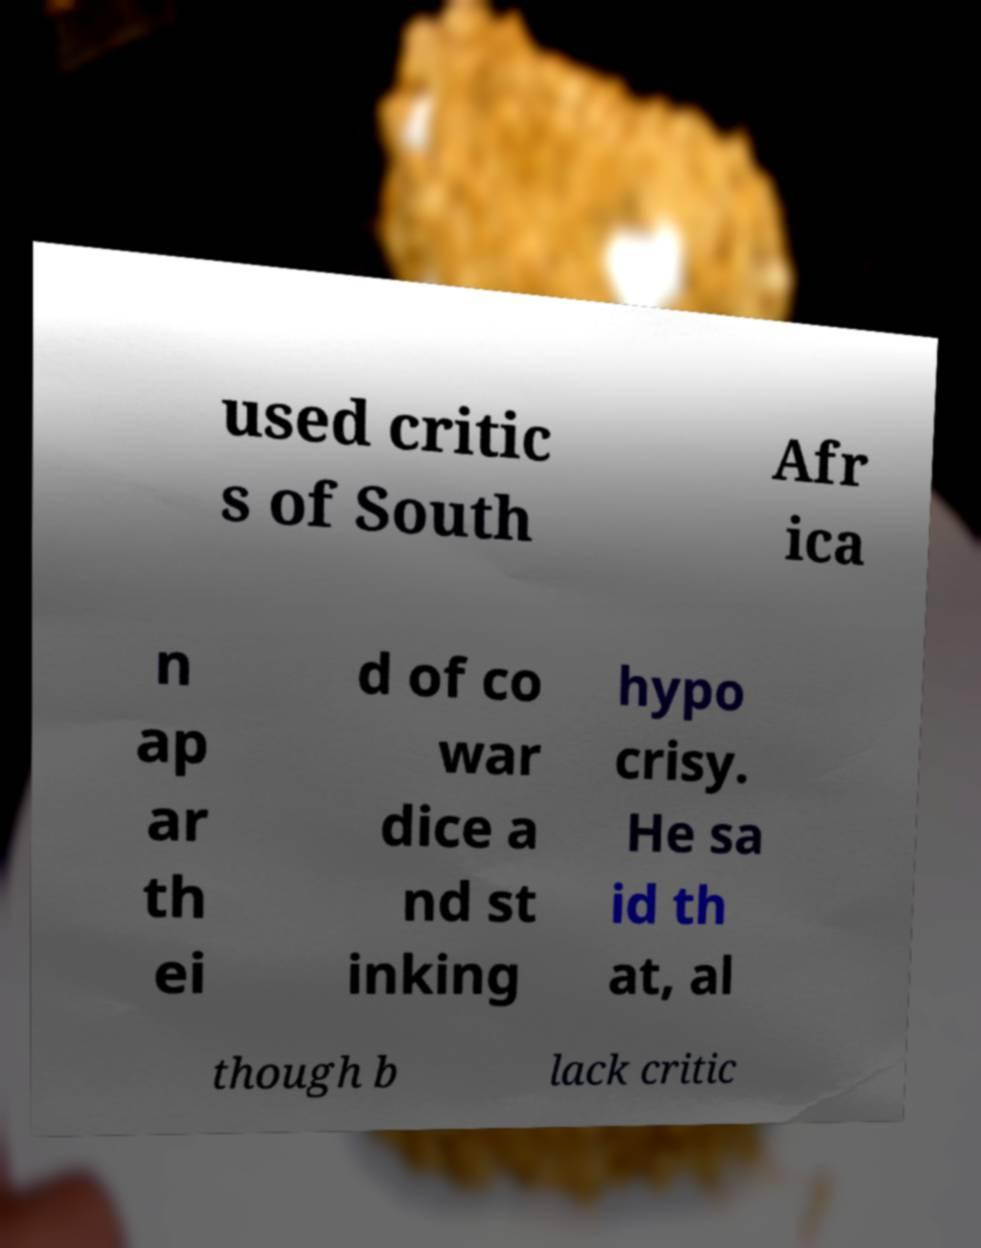Can you read and provide the text displayed in the image?This photo seems to have some interesting text. Can you extract and type it out for me? used critic s of South Afr ica n ap ar th ei d of co war dice a nd st inking hypo crisy. He sa id th at, al though b lack critic 